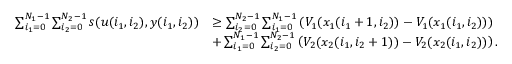Convert formula to latex. <formula><loc_0><loc_0><loc_500><loc_500>\begin{array} { r l } { \sum _ { i _ { 1 } = 0 } ^ { N _ { 1 } - 1 } \sum _ { i _ { 2 } = 0 } ^ { N _ { 2 } - 1 } s ( u ( i _ { 1 } , i _ { 2 } ) , y ( i _ { 1 } , i _ { 2 } ) ) } & { \geq \sum _ { i _ { 2 } = 0 } ^ { N _ { 2 } - 1 } \sum _ { i _ { 1 } = 0 } ^ { N _ { 1 } - 1 } \left ( V _ { 1 } ( x _ { 1 } ( i _ { 1 } + 1 , i _ { 2 } ) ) - V _ { 1 } ( x _ { 1 } ( i _ { 1 } , i _ { 2 } ) ) \right ) } \\ & { + \sum _ { i _ { 1 } = 0 } ^ { N _ { 1 } - 1 } \sum _ { i _ { 2 } = 0 } ^ { N _ { 2 } - 1 } \left ( V _ { 2 } ( x _ { 2 } ( i _ { 1 } , i _ { 2 } + 1 ) ) - V _ { 2 } ( x _ { 2 } ( i _ { 1 } , i _ { 2 } ) ) \right ) . } \end{array}</formula> 